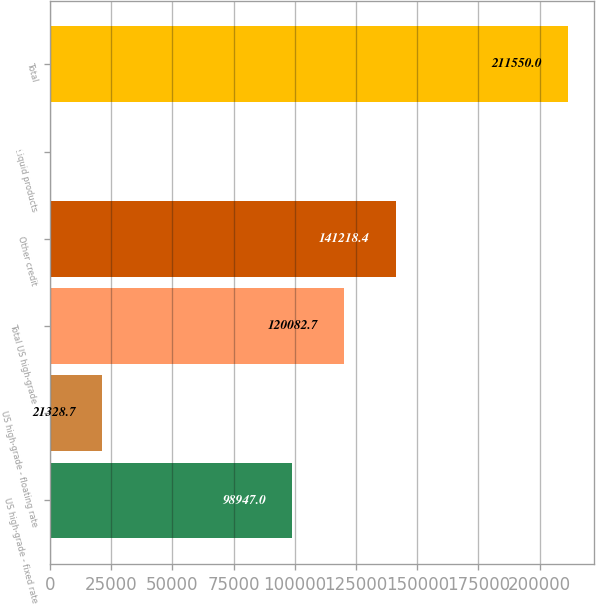Convert chart. <chart><loc_0><loc_0><loc_500><loc_500><bar_chart><fcel>US high-grade - fixed rate<fcel>US high-grade - floating rate<fcel>Total US high-grade<fcel>Other credit<fcel>Liquid products<fcel>Total<nl><fcel>98947<fcel>21328.7<fcel>120083<fcel>141218<fcel>193<fcel>211550<nl></chart> 